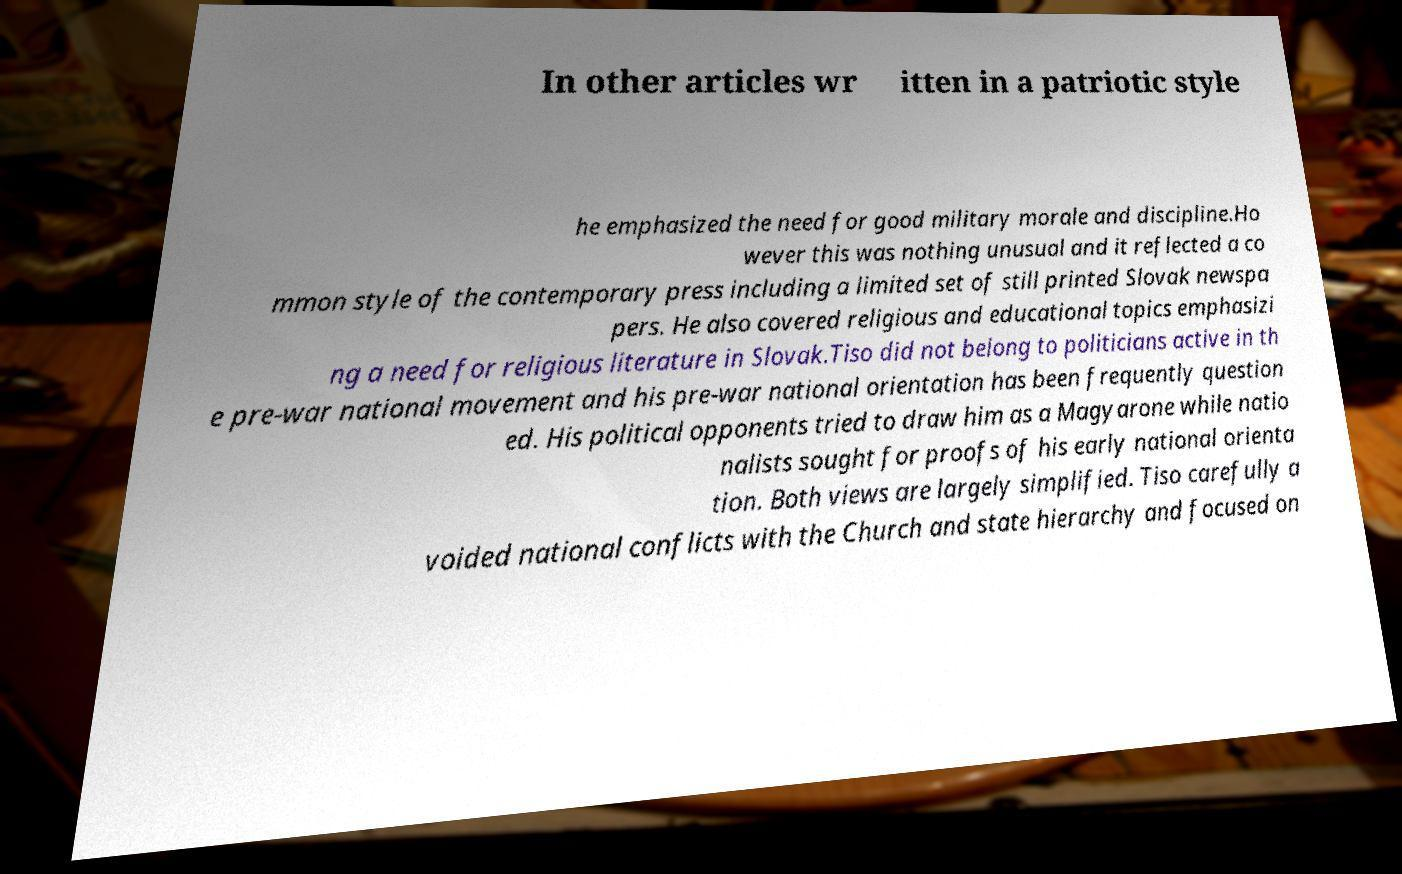For documentation purposes, I need the text within this image transcribed. Could you provide that? In other articles wr itten in a patriotic style he emphasized the need for good military morale and discipline.Ho wever this was nothing unusual and it reflected a co mmon style of the contemporary press including a limited set of still printed Slovak newspa pers. He also covered religious and educational topics emphasizi ng a need for religious literature in Slovak.Tiso did not belong to politicians active in th e pre-war national movement and his pre-war national orientation has been frequently question ed. His political opponents tried to draw him as a Magyarone while natio nalists sought for proofs of his early national orienta tion. Both views are largely simplified. Tiso carefully a voided national conflicts with the Church and state hierarchy and focused on 